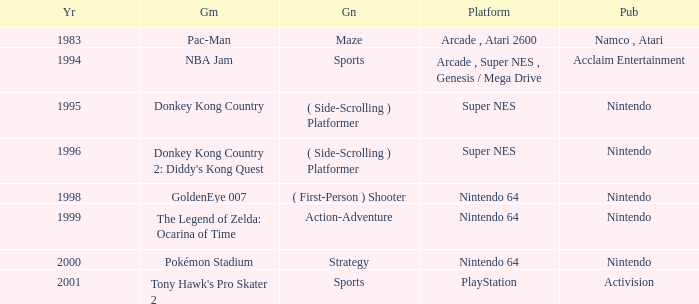Which Genre has a Year larger than 1999, and a Game of tony hawk's pro skater 2? Sports. 